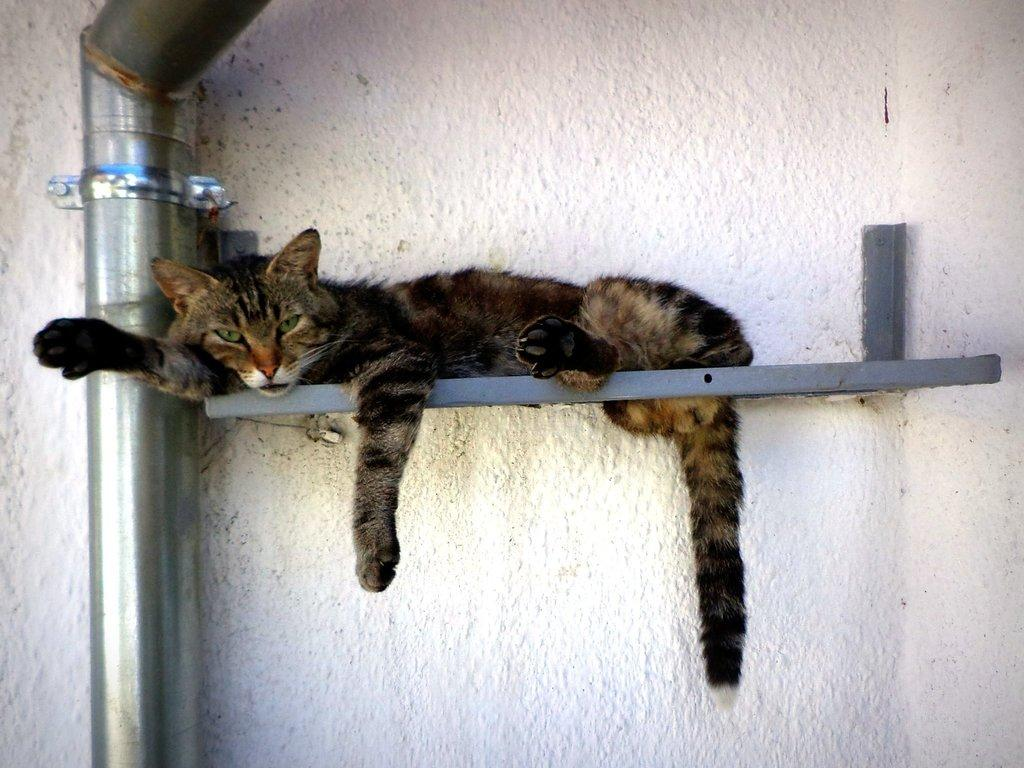What animal can be seen in the image? There is a cat in the image. What is the cat lying on? The cat is lying on a metal object. Where is the metal object attached? The metal object is attached to a white color wall. What is the position of the cat and metal object in the image? The cat and metal object are in the middle of the image. What else can be seen on the left side of the image? There is a pipe on the left side of the image. Can you tell me how many people are requesting the cat's freedom in the image? There is no mention of people or a request for the cat's freedom in the image. 